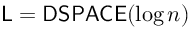<formula> <loc_0><loc_0><loc_500><loc_500>{ L } = { D S P A C E } ( \log n )</formula> 